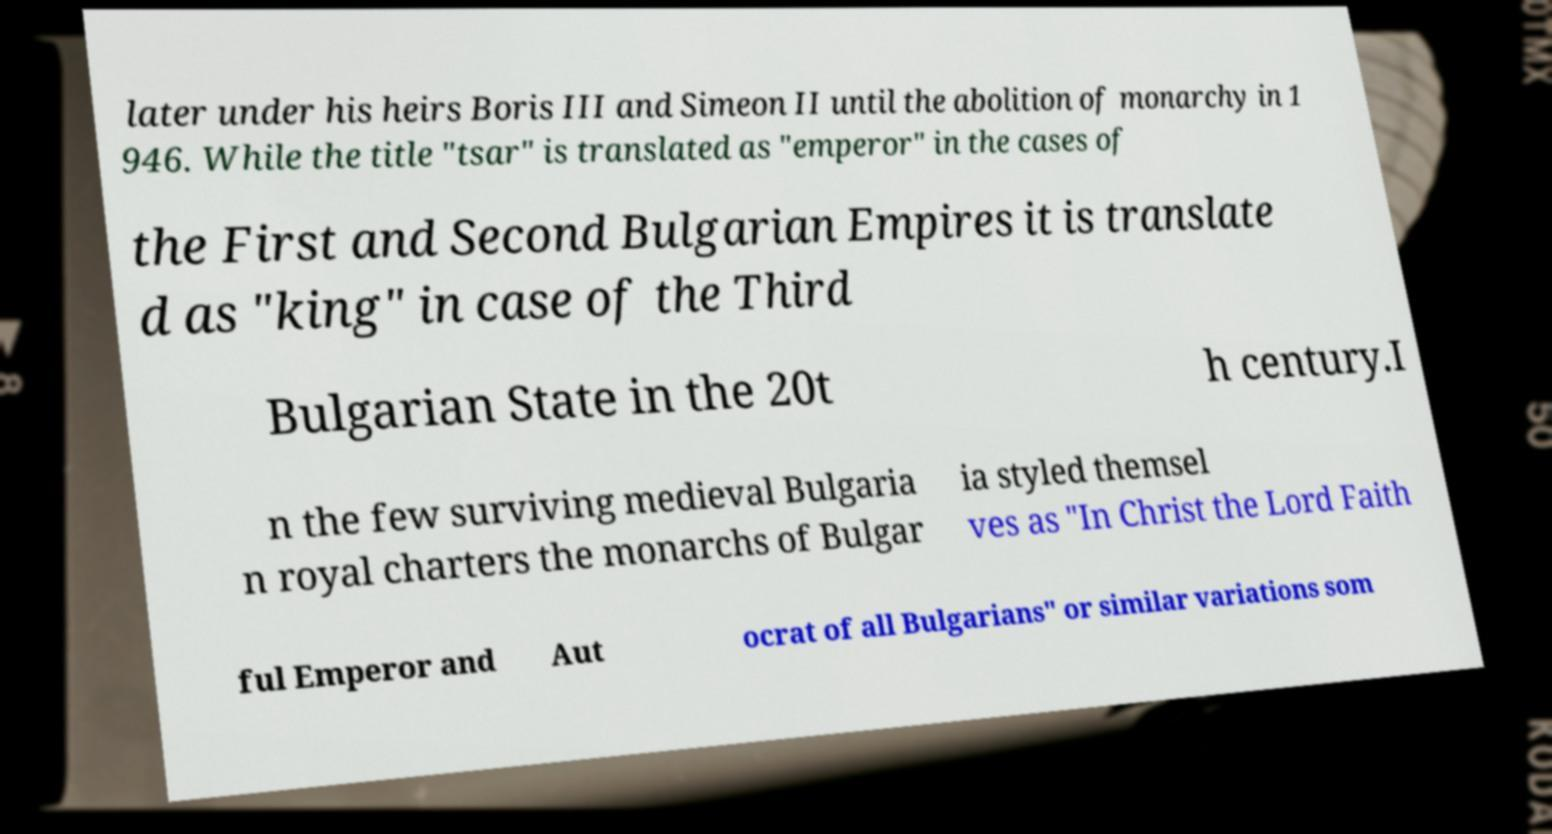Please read and relay the text visible in this image. What does it say? later under his heirs Boris III and Simeon II until the abolition of monarchy in 1 946. While the title "tsar" is translated as "emperor" in the cases of the First and Second Bulgarian Empires it is translate d as "king" in case of the Third Bulgarian State in the 20t h century.I n the few surviving medieval Bulgaria n royal charters the monarchs of Bulgar ia styled themsel ves as "In Christ the Lord Faith ful Emperor and Aut ocrat of all Bulgarians" or similar variations som 